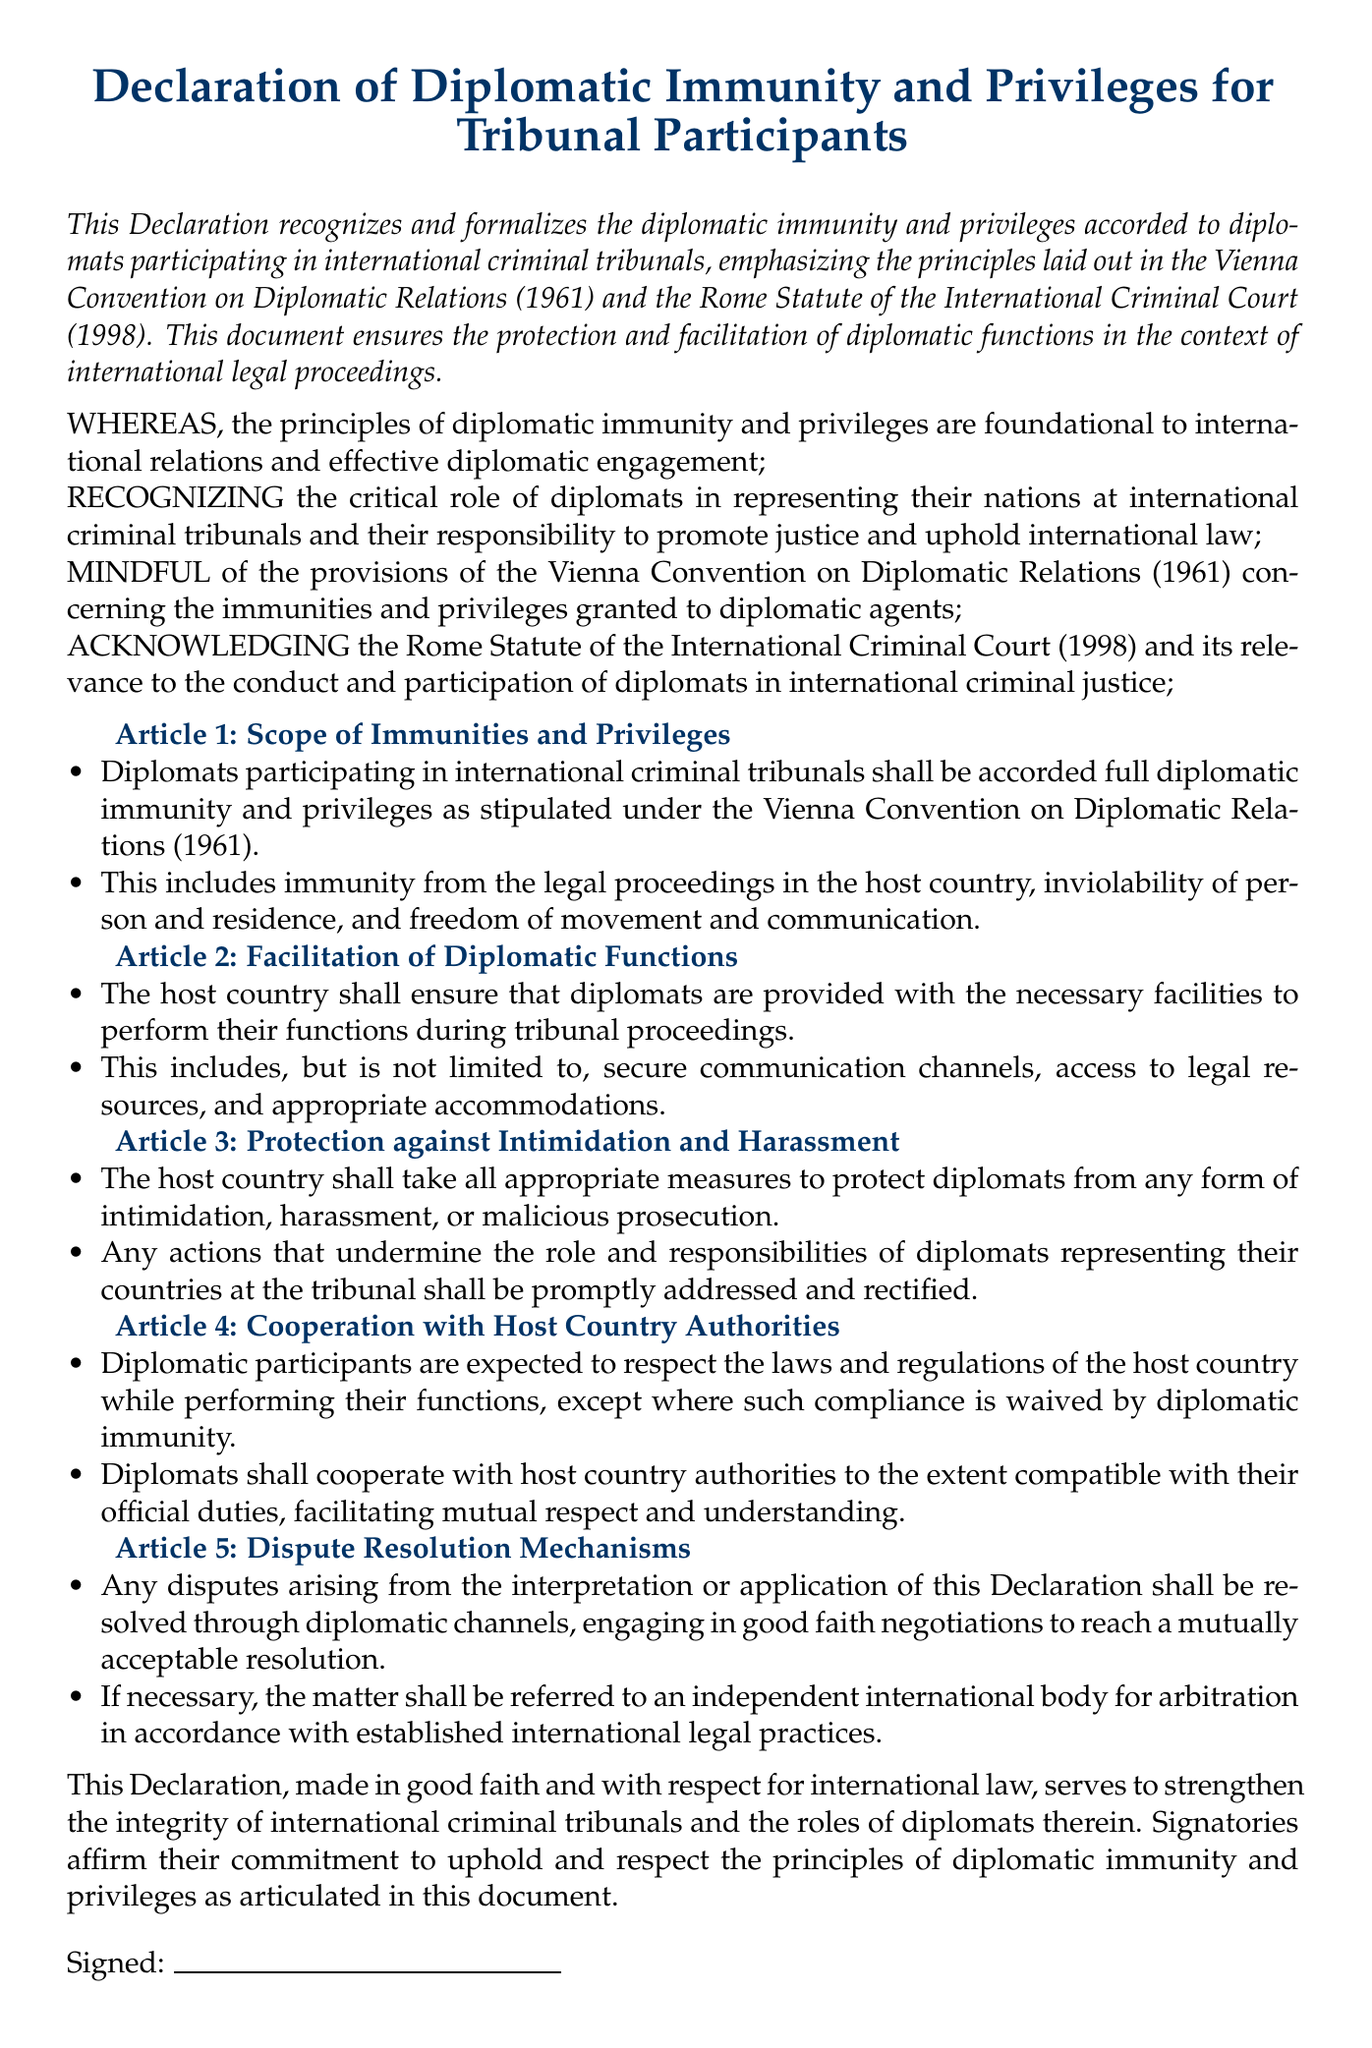What is the title of the document? The title, as stated in the center of the document, identifies the subject matter of the text.
Answer: Declaration of Diplomatic Immunity and Privileges for Tribunal Participants What year was the Vienna Convention on Diplomatic Relations established? The document references the Vienna Convention, which is a foundational treaty in international law, specifically mentioning its year of establishment.
Answer: 1961 What article addresses the Scope of Immunities and Privileges? The document is organized into articles, and this specific question addresses the content of one of those articles.
Answer: Article 1 What is the purpose of Article 3? Article 3 outlines the measures that the host country should take regarding diplomats, focusing on their safety and security.
Answer: Protection against Intimidation and Harassment How are disputes resolved according to the document? The document specifies a process for addressing conflicts related to its interpretation or application, indicating how parties should navigate disagreements.
Answer: Diplomatic channels What is emphasized in the concluding statement of the document? The concluding portion reflects the overall commitment and intention of the signatories regarding the principles discussed in the Declaration.
Answer: Respect for international law 